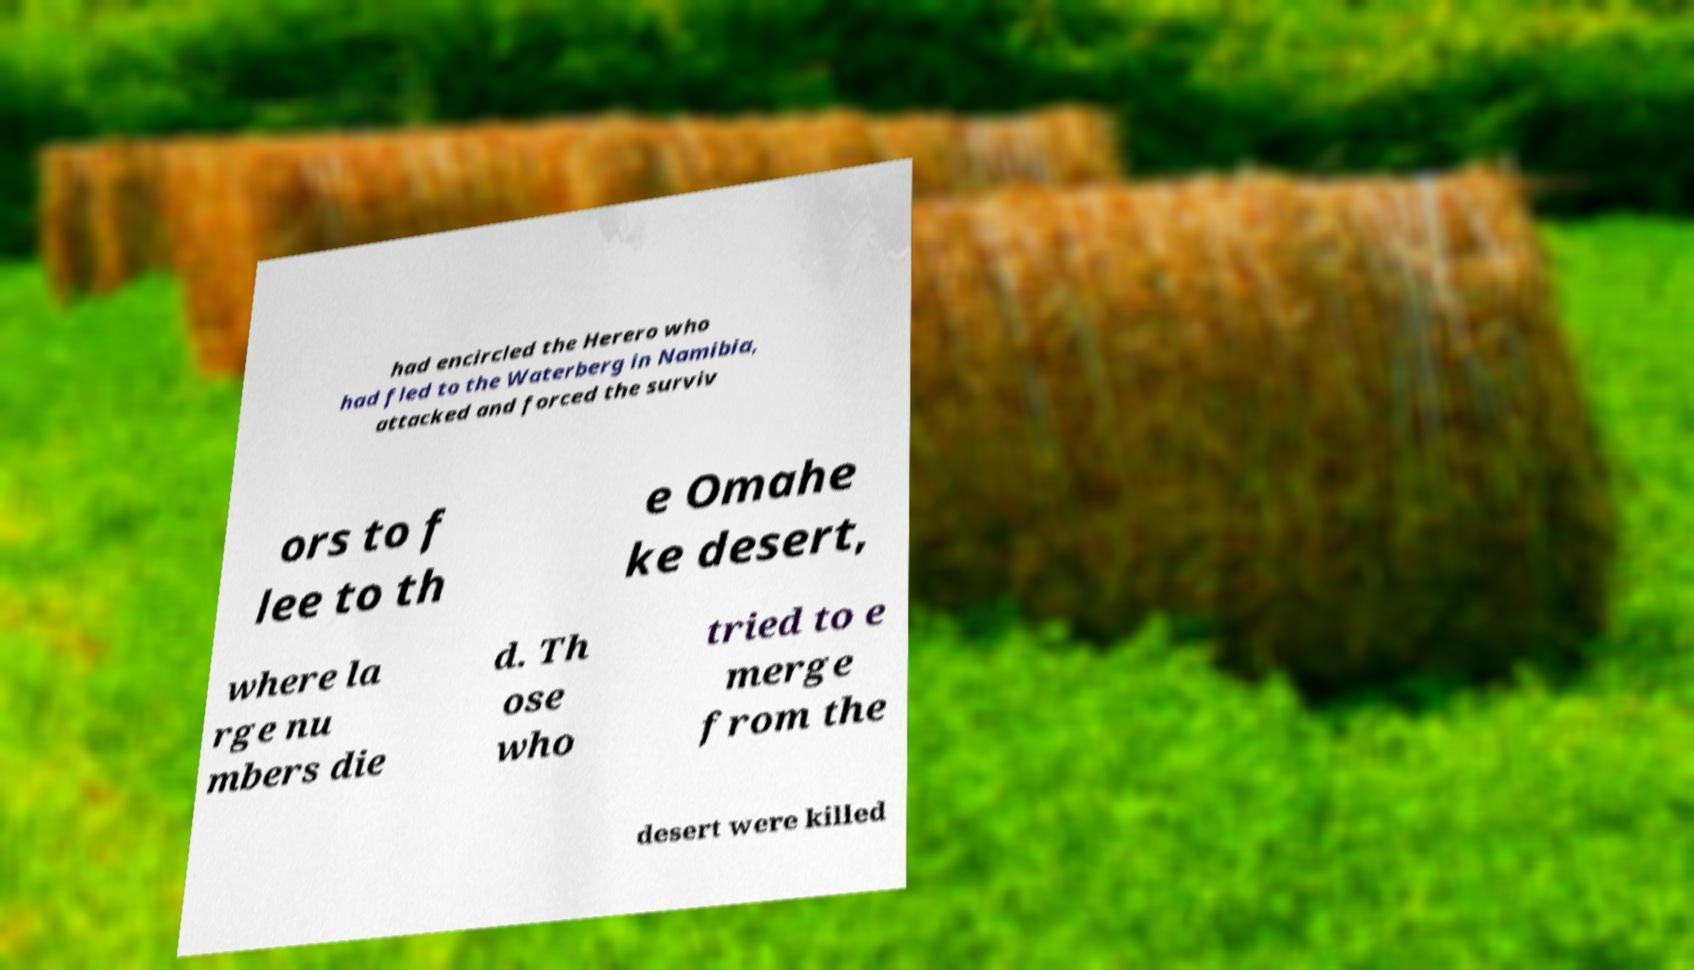There's text embedded in this image that I need extracted. Can you transcribe it verbatim? had encircled the Herero who had fled to the Waterberg in Namibia, attacked and forced the surviv ors to f lee to th e Omahe ke desert, where la rge nu mbers die d. Th ose who tried to e merge from the desert were killed 